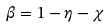Convert formula to latex. <formula><loc_0><loc_0><loc_500><loc_500>\beta = 1 - \eta - \chi</formula> 